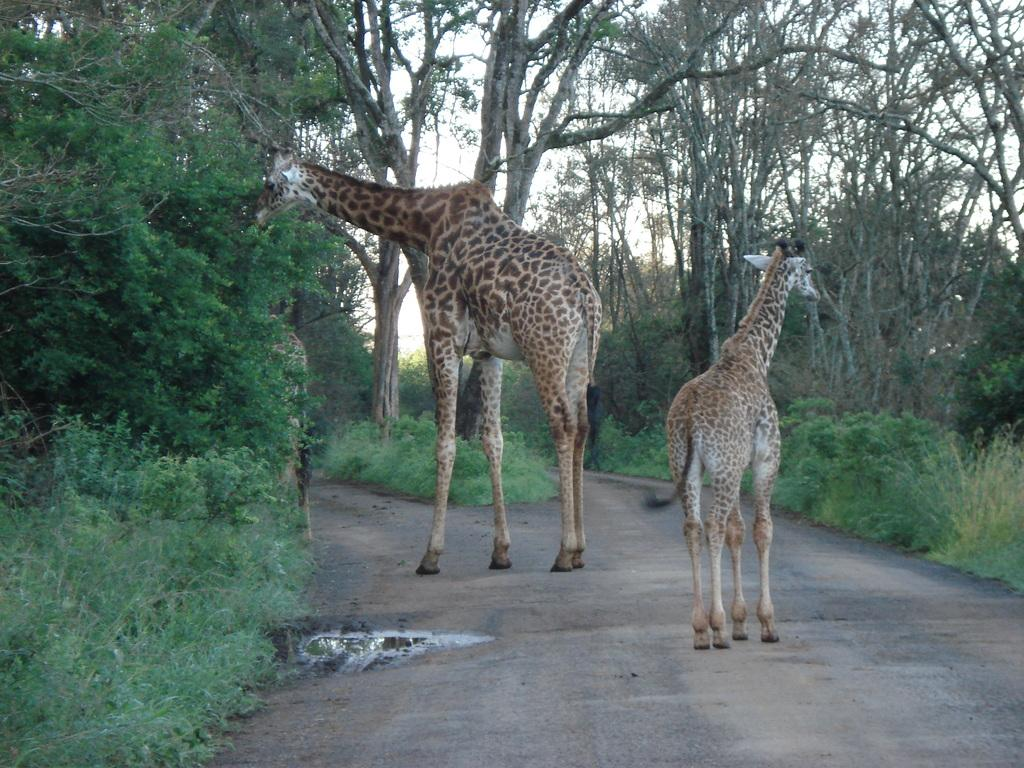What animals can be seen on the road in the image? There are giraffes on the road in the image. What type of vegetation is present in the image? There are plants and trees in the image. What is visible in the background of the image? The sky is visible in the image. What is the profit made by the giraffes in the image? There is no mention of profit in the image, as it features giraffes on the road and does not involve any financial transactions. 